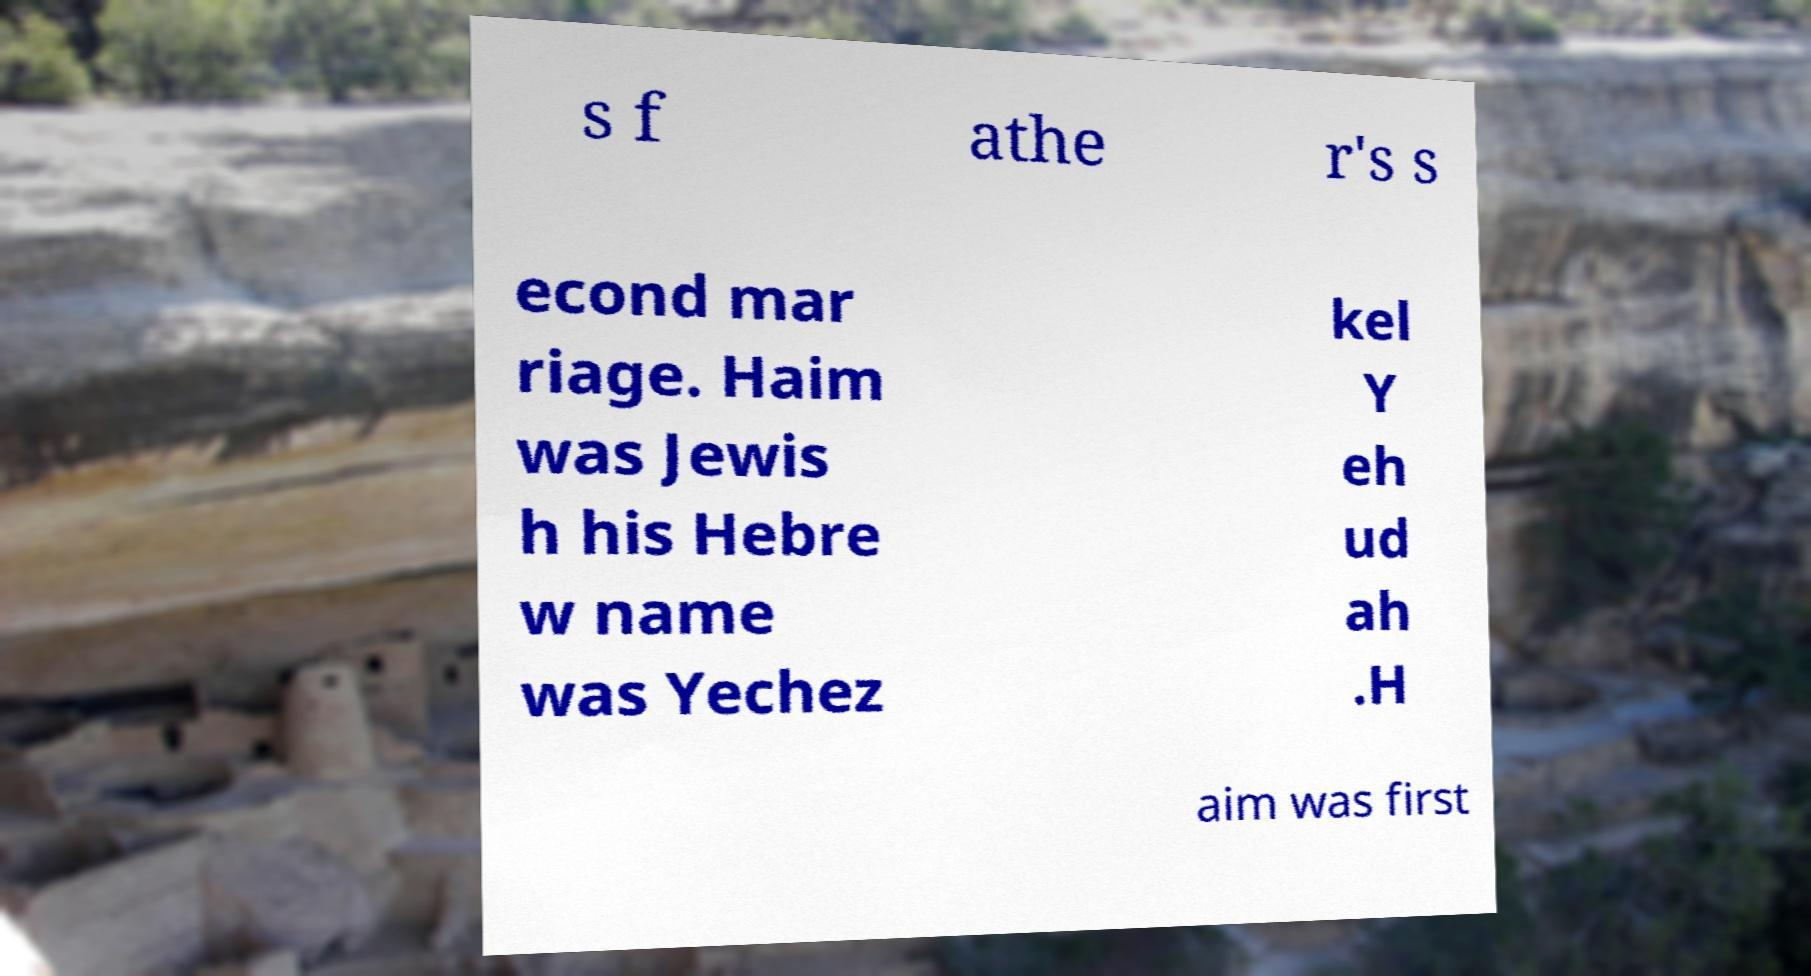Can you read and provide the text displayed in the image?This photo seems to have some interesting text. Can you extract and type it out for me? s f athe r's s econd mar riage. Haim was Jewis h his Hebre w name was Yechez kel Y eh ud ah .H aim was first 